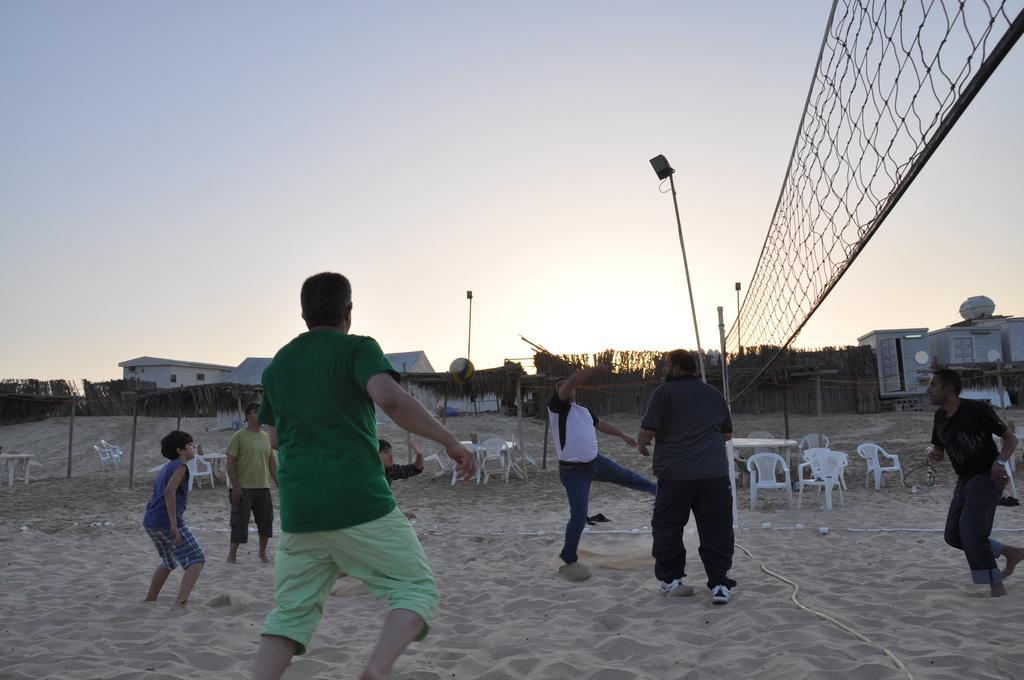Describe this image in one or two sentences. In this picture we can see some people playing the volleyball game in the ground. Behind we can see white chairs and small houses. On the top we can see the sky. 